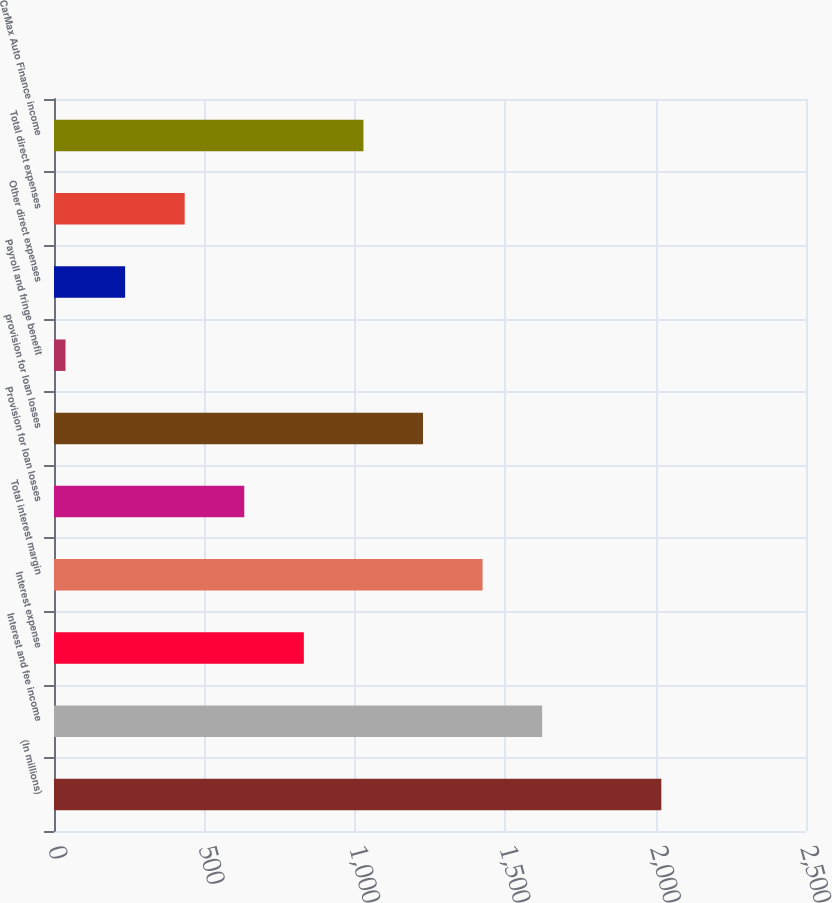Convert chart to OTSL. <chart><loc_0><loc_0><loc_500><loc_500><bar_chart><fcel>(In millions)<fcel>Interest and fee income<fcel>Interest expense<fcel>Total interest margin<fcel>Provision for loan losses<fcel>provision for loan losses<fcel>Payroll and fringe benefit<fcel>Other direct expenses<fcel>Total direct expenses<fcel>CarMax Auto Finance income<nl><fcel>2019<fcel>1622.86<fcel>830.58<fcel>1424.79<fcel>632.51<fcel>1226.72<fcel>38.3<fcel>236.37<fcel>434.44<fcel>1028.65<nl></chart> 